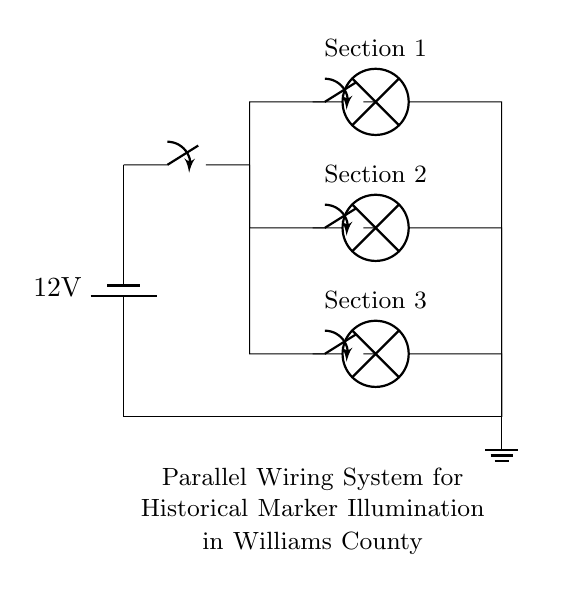What is the voltage of the power source? The voltage of the battery is marked as 12 volts in the circuit diagram, indicating the potential difference the battery provides to the circuit.
Answer: 12 volts How many lamps are present in the circuit? There are three lamps labeled as Section 1, Section 2, and Section 3 in the parallel branches of the circuit diagram.
Answer: Three What is the configuration type of this circuit? The circuit is configured in parallel, as indicated by the multiple branches where each lamp is connected directly to the power source, allowing each section to operate independently.
Answer: Parallel What components have individual switches? There are individual switches for each lamp, located in the respective branches of the circuit diagram, allowing control of each lamp's illumination separately.
Answer: Three switches What would happen to the other sections if one lamp fails? If one lamp fails in a parallel circuit, the other lamps will continue to operate normally because they are connected separately to the power source.
Answer: They will remain lit What is the purpose of the main switch? The main switch controls the overall power flow to the entire circuit, allowing all lamps to be turned on or off simultaneously.
Answer: Control power flow 